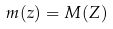<formula> <loc_0><loc_0><loc_500><loc_500>m ( z ) = M ( Z )</formula> 